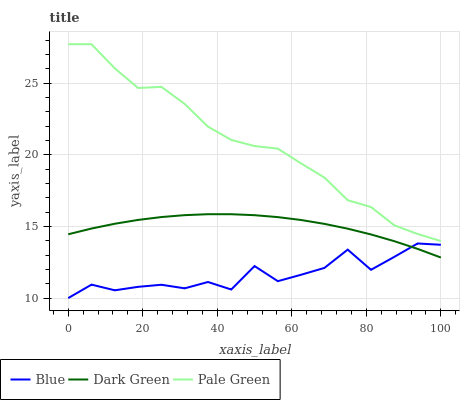Does Blue have the minimum area under the curve?
Answer yes or no. Yes. Does Pale Green have the maximum area under the curve?
Answer yes or no. Yes. Does Dark Green have the minimum area under the curve?
Answer yes or no. No. Does Dark Green have the maximum area under the curve?
Answer yes or no. No. Is Dark Green the smoothest?
Answer yes or no. Yes. Is Blue the roughest?
Answer yes or no. Yes. Is Pale Green the smoothest?
Answer yes or no. No. Is Pale Green the roughest?
Answer yes or no. No. Does Blue have the lowest value?
Answer yes or no. Yes. Does Dark Green have the lowest value?
Answer yes or no. No. Does Pale Green have the highest value?
Answer yes or no. Yes. Does Dark Green have the highest value?
Answer yes or no. No. Is Dark Green less than Pale Green?
Answer yes or no. Yes. Is Pale Green greater than Dark Green?
Answer yes or no. Yes. Does Blue intersect Dark Green?
Answer yes or no. Yes. Is Blue less than Dark Green?
Answer yes or no. No. Is Blue greater than Dark Green?
Answer yes or no. No. Does Dark Green intersect Pale Green?
Answer yes or no. No. 